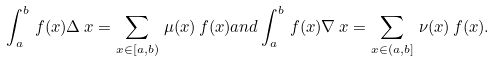<formula> <loc_0><loc_0><loc_500><loc_500>\int _ { a } ^ { b } \, f ( x ) \Delta \, x = \sum _ { x \in [ a , b ) } \, \mu ( x ) \, f ( x ) a n d \int _ { a } ^ { b } \, f ( x ) \nabla \, x = \sum _ { x \in ( a , b ] } \, \nu ( x ) \, f ( x ) .</formula> 